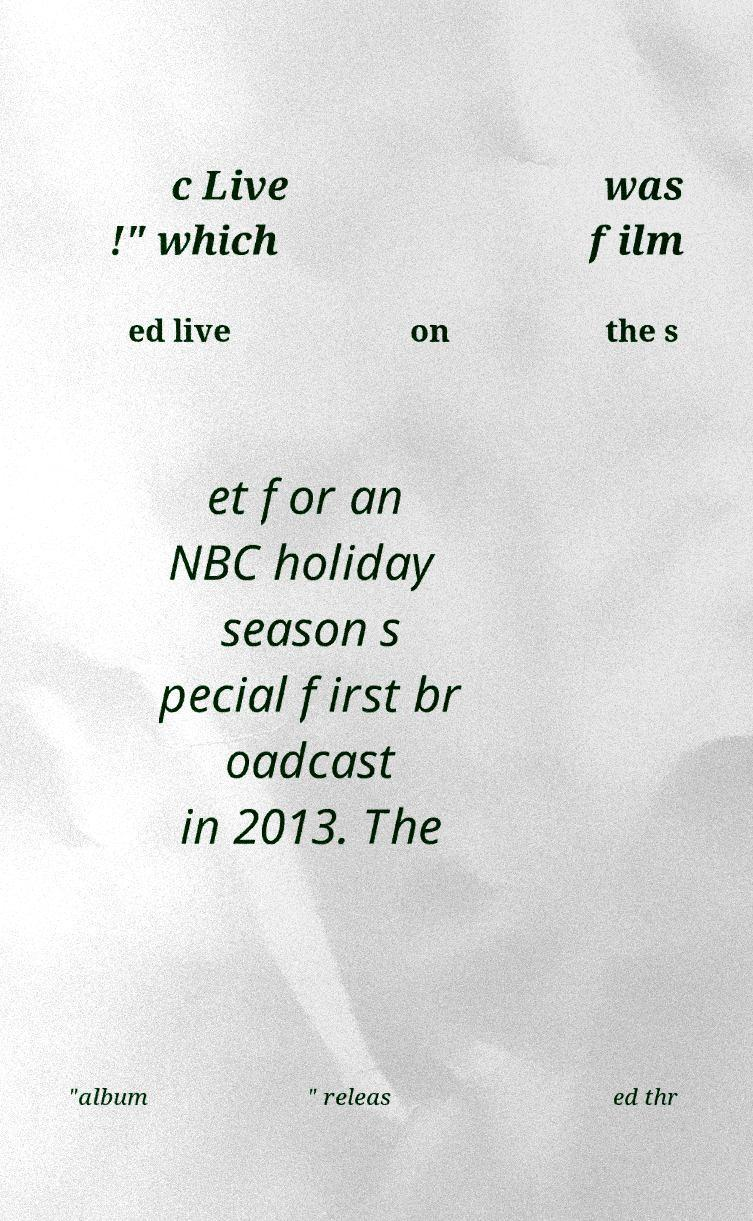I need the written content from this picture converted into text. Can you do that? c Live !" which was film ed live on the s et for an NBC holiday season s pecial first br oadcast in 2013. The "album " releas ed thr 